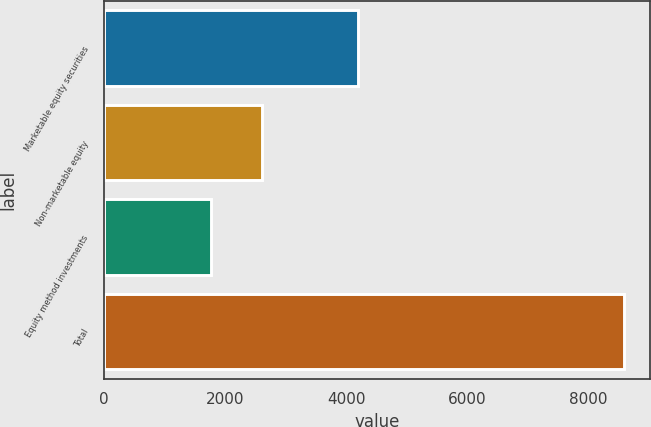Convert chart. <chart><loc_0><loc_0><loc_500><loc_500><bar_chart><fcel>Marketable equity securities<fcel>Non-marketable equity<fcel>Equity method investments<fcel>Total<nl><fcel>4192<fcel>2613<fcel>1774<fcel>8579<nl></chart> 